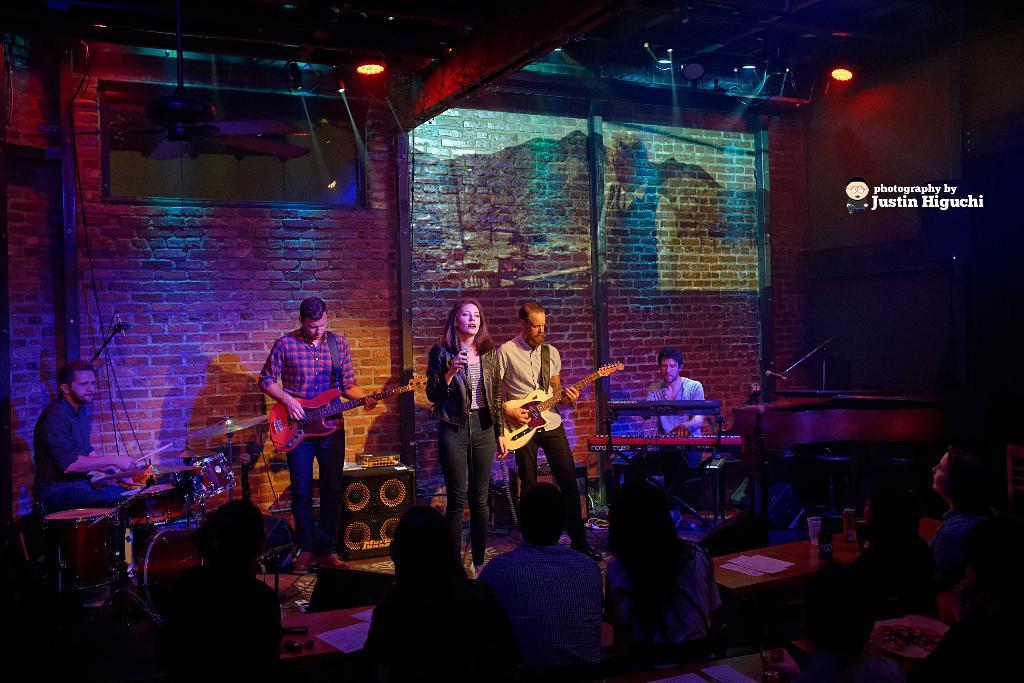In one or two sentences, can you explain what this image depicts? This picture is of inside. In the foreground we can see group of persons sitting and there is a table on the top of which some papers and glasses are placed. On the right there is a man sitting and playing the musical keyboard. In the center there is a woman and a man standing. There is a Man standing and playing guitar. In the left corner there is a man sitting and playing drums. In the background we can see the brick wall and focusing lights. 